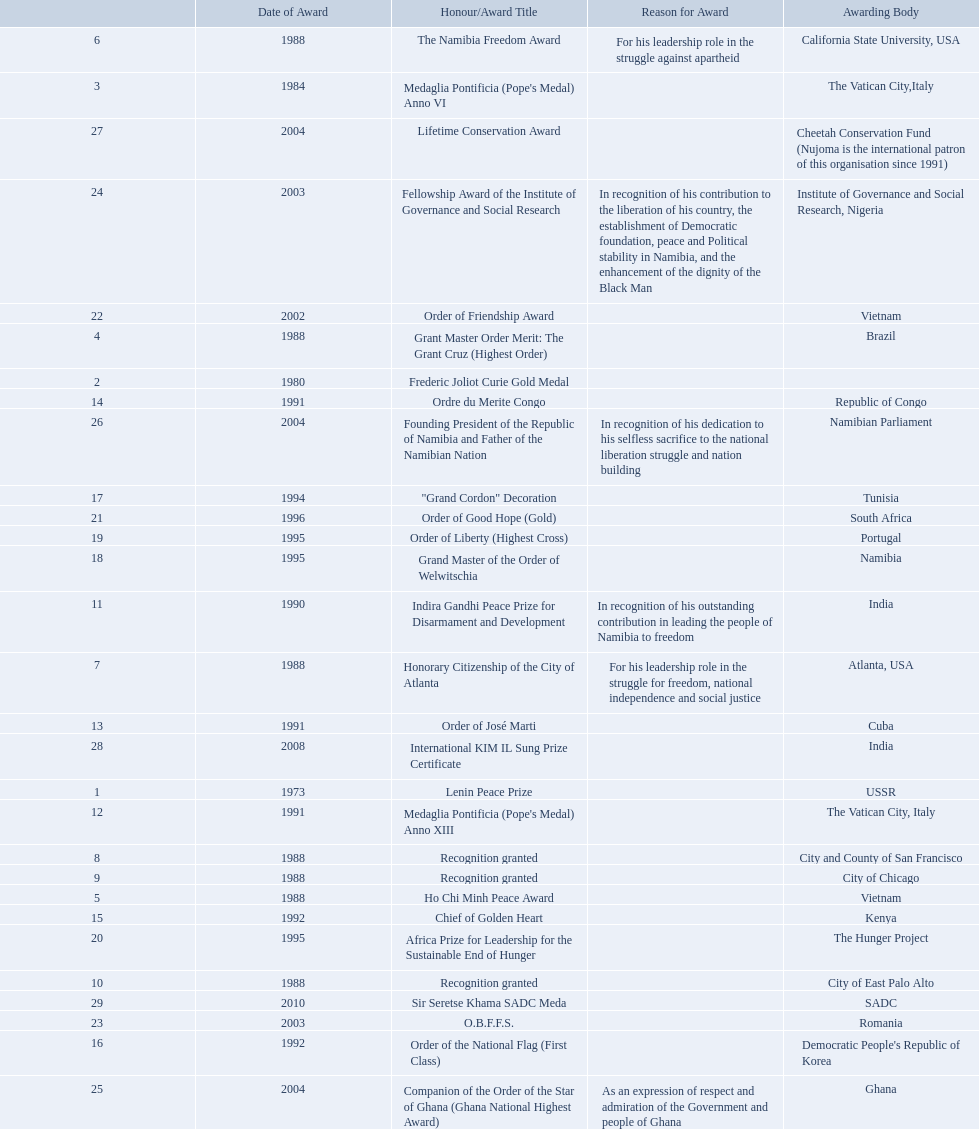Which awarding bodies have recognized sam nujoma? USSR, , The Vatican City,Italy, Brazil, Vietnam, California State University, USA, Atlanta, USA, City and County of San Francisco, City of Chicago, City of East Palo Alto, India, The Vatican City, Italy, Cuba, Republic of Congo, Kenya, Democratic People's Republic of Korea, Tunisia, Namibia, Portugal, The Hunger Project, South Africa, Vietnam, Romania, Institute of Governance and Social Research, Nigeria, Ghana, Namibian Parliament, Cheetah Conservation Fund (Nujoma is the international patron of this organisation since 1991), India, SADC. And what was the title of each award or honour? Lenin Peace Prize, Frederic Joliot Curie Gold Medal, Medaglia Pontificia (Pope's Medal) Anno VI, Grant Master Order Merit: The Grant Cruz (Highest Order), Ho Chi Minh Peace Award, The Namibia Freedom Award, Honorary Citizenship of the City of Atlanta, Recognition granted, Recognition granted, Recognition granted, Indira Gandhi Peace Prize for Disarmament and Development, Medaglia Pontificia (Pope's Medal) Anno XIII, Order of José Marti, Ordre du Merite Congo, Chief of Golden Heart, Order of the National Flag (First Class), "Grand Cordon" Decoration, Grand Master of the Order of Welwitschia, Order of Liberty (Highest Cross), Africa Prize for Leadership for the Sustainable End of Hunger, Order of Good Hope (Gold), Order of Friendship Award, O.B.F.F.S., Fellowship Award of the Institute of Governance and Social Research, Companion of the Order of the Star of Ghana (Ghana National Highest Award), Founding President of the Republic of Namibia and Father of the Namibian Nation, Lifetime Conservation Award, International KIM IL Sung Prize Certificate, Sir Seretse Khama SADC Meda. Of those, which nation awarded him the o.b.f.f.s.? Romania. 